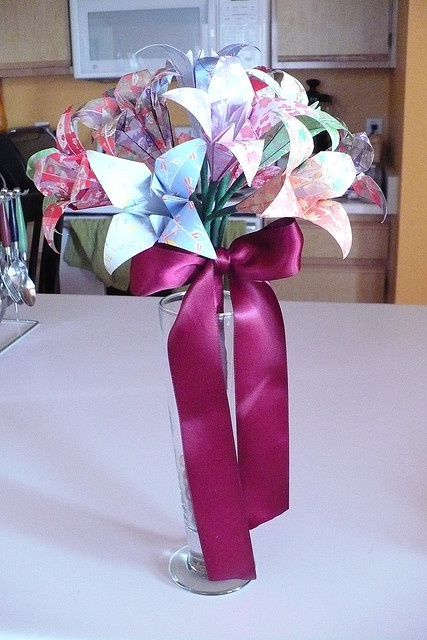Describe the objects in this image and their specific colors. I can see dining table in gray, lavender, purple, and darkgray tones, microwave in gray, darkgray, and lavender tones, vase in gray, darkgray, purple, and lavender tones, spoon in gray, white, navy, and darkgray tones, and spoon in gray, teal, white, and lightblue tones in this image. 